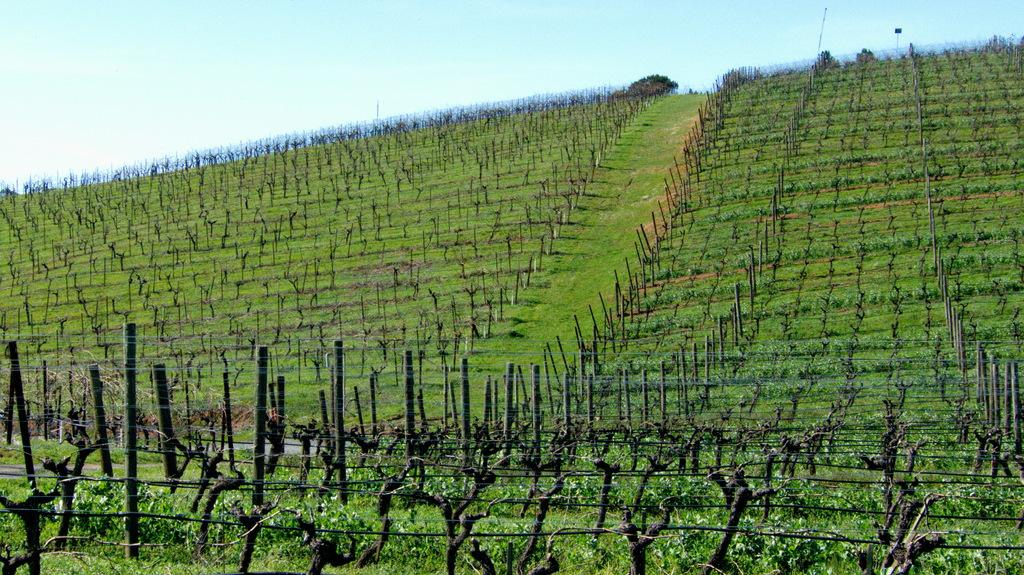What can be found at the bottom of the image? At the bottom of the image, there are plants, a fence, poles, and wooden sticks. What is present in the middle of the image? In the middle of the image, there are plants, grass, a fence, trees, and the sky is visible. How many different elements can be seen at the bottom of the image? There are four different elements at the bottom of the image: plants, a fence, poles, and wooden sticks. What type of mark can be seen on the trees in the image? There is no mention of any marks on the trees in the image. How many sails are visible in the image? There are no sails present in the image. 